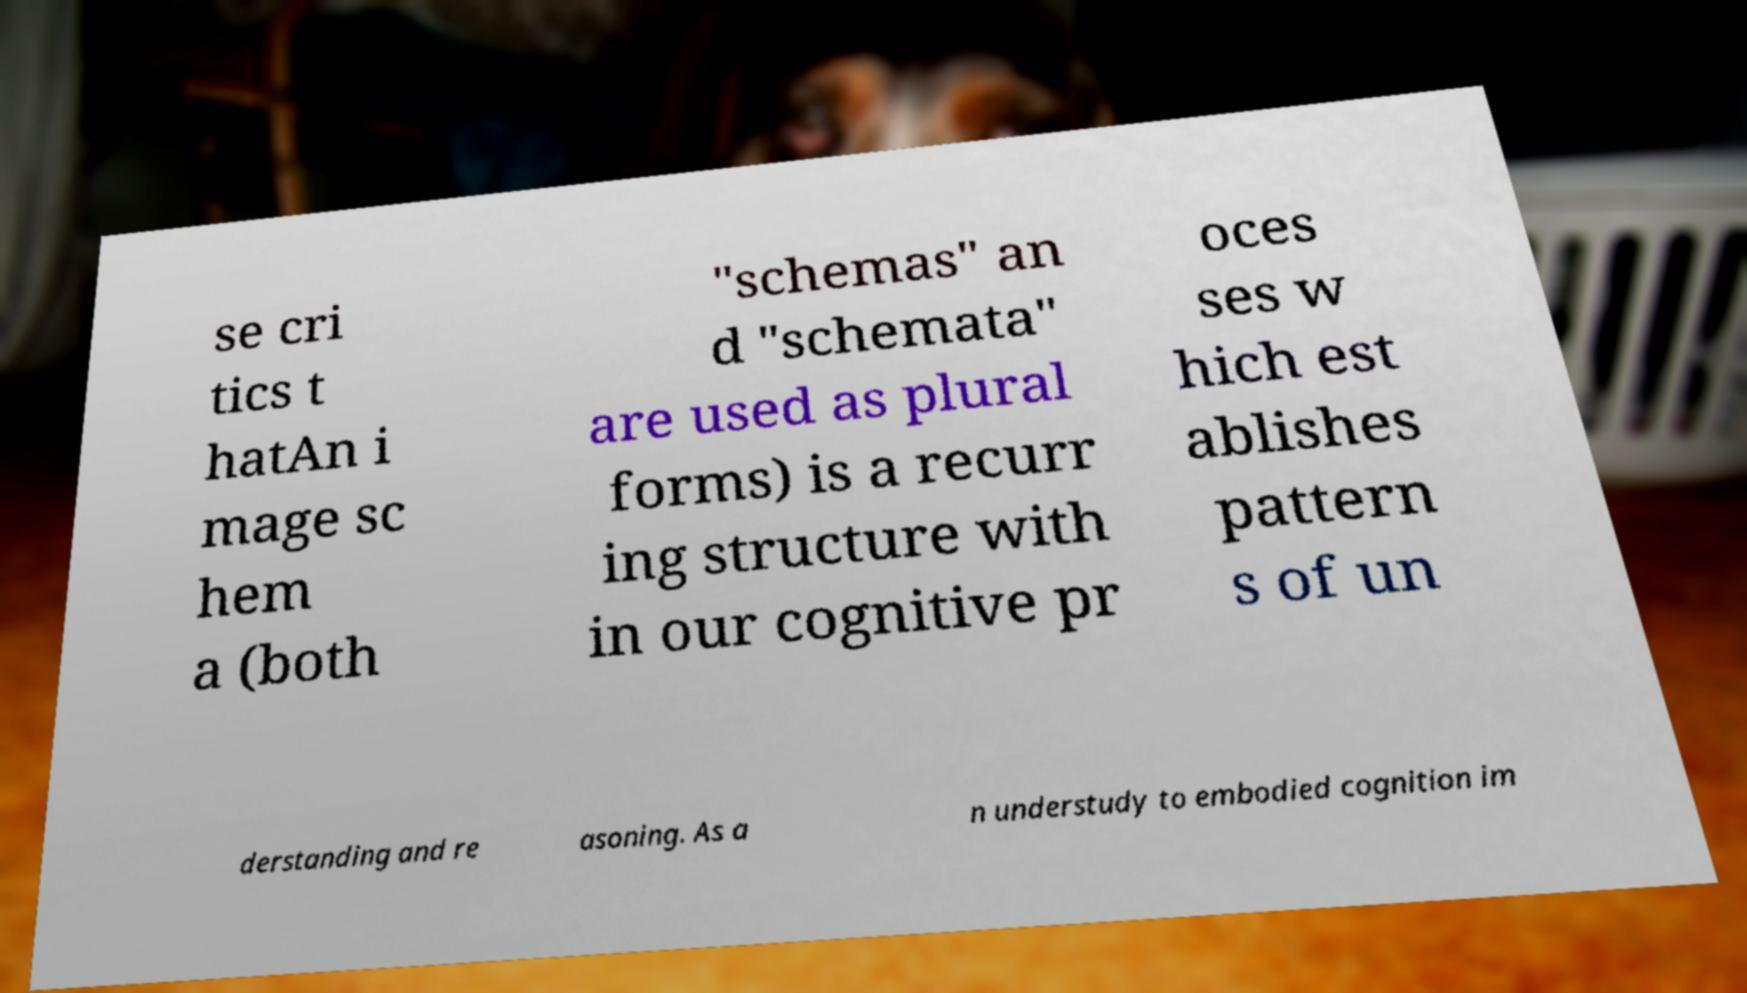Could you assist in decoding the text presented in this image and type it out clearly? se cri tics t hatAn i mage sc hem a (both "schemas" an d "schemata" are used as plural forms) is a recurr ing structure with in our cognitive pr oces ses w hich est ablishes pattern s of un derstanding and re asoning. As a n understudy to embodied cognition im 